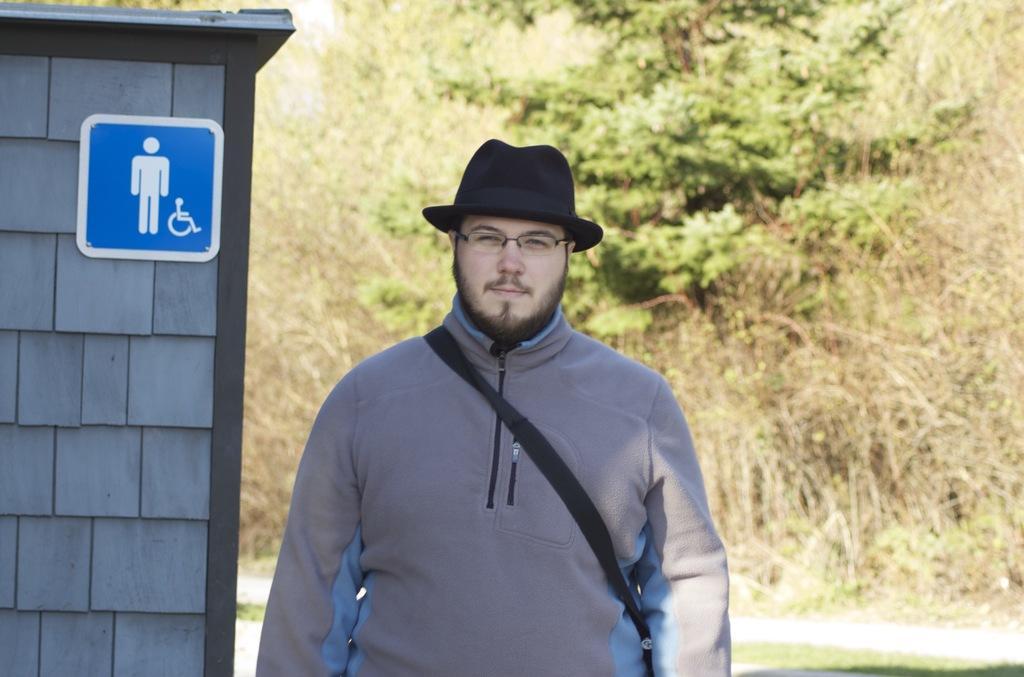In one or two sentences, can you explain what this image depicts? This is the man standing and smiling. He wore a jerkin, spectacle and a hat. This looks like a signboard, which is attached to the wall. In the background, I can see the trees. 